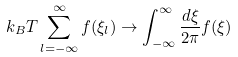<formula> <loc_0><loc_0><loc_500><loc_500>k _ { B } T \sum _ { l = - \infty } ^ { \infty } f ( \xi _ { l } ) \to \int _ { - \infty } ^ { \infty } \frac { d \xi } { 2 \pi } f ( \xi )</formula> 